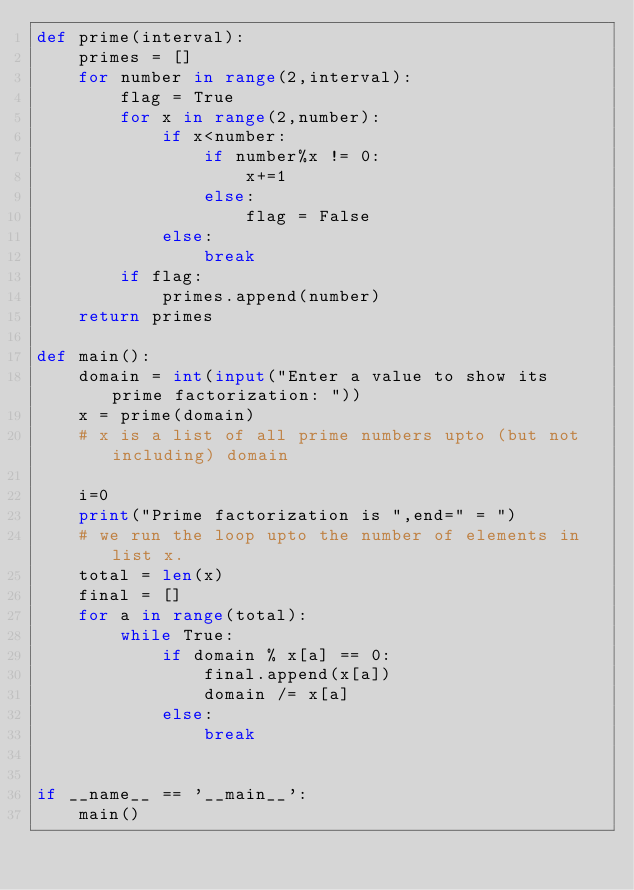Convert code to text. <code><loc_0><loc_0><loc_500><loc_500><_Python_>def prime(interval):
	primes = []
	for number in range(2,interval):
	    flag = True
	    for x in range(2,number):
	        if x<number:
	            if number%x != 0:
	                x+=1
	            else:
	                flag = False
	        else:
	            break
	    if flag:
	        primes.append(number)
	return primes

def main():
	domain = int(input("Enter a value to show its prime factorization: "))
	x = prime(domain)
	# x is a list of all prime numbers upto (but not including) domain
	
	i=0
	print("Prime factorization is ",end=" = ")
	# we run the loop upto the number of elements in list x.
	total = len(x)
	final = []
	for a in range(total):
		while True:
			if domain % x[a] == 0:
				final.append(x[a])
				domain /= x[a] 
			else:
				break


if __name__ == '__main__':
	main()</code> 